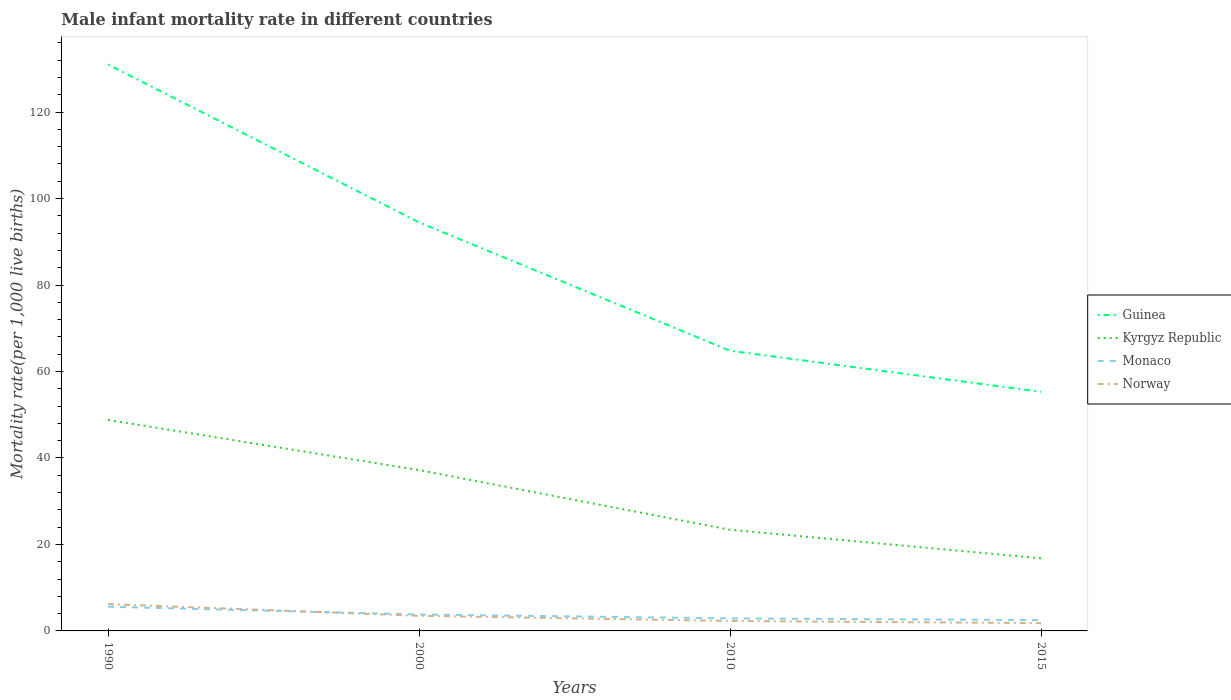Does the line corresponding to Monaco intersect with the line corresponding to Guinea?
Offer a terse response. No. In which year was the male infant mortality rate in Guinea maximum?
Keep it short and to the point. 2015. What is the total male infant mortality rate in Kyrgyz Republic in the graph?
Provide a short and direct response. 11.6. What is the difference between the highest and the second highest male infant mortality rate in Monaco?
Offer a very short reply. 3.1. What is the difference between the highest and the lowest male infant mortality rate in Monaco?
Your answer should be very brief. 2. How many years are there in the graph?
Ensure brevity in your answer.  4. Does the graph contain any zero values?
Make the answer very short. No. Does the graph contain grids?
Make the answer very short. No. Where does the legend appear in the graph?
Ensure brevity in your answer.  Center right. What is the title of the graph?
Your response must be concise. Male infant mortality rate in different countries. What is the label or title of the Y-axis?
Provide a succinct answer. Mortality rate(per 1,0 live births). What is the Mortality rate(per 1,000 live births) of Guinea in 1990?
Your answer should be compact. 131. What is the Mortality rate(per 1,000 live births) in Kyrgyz Republic in 1990?
Offer a terse response. 48.8. What is the Mortality rate(per 1,000 live births) of Monaco in 1990?
Make the answer very short. 5.6. What is the Mortality rate(per 1,000 live births) in Norway in 1990?
Provide a short and direct response. 6.2. What is the Mortality rate(per 1,000 live births) of Guinea in 2000?
Your answer should be very brief. 94.5. What is the Mortality rate(per 1,000 live births) of Kyrgyz Republic in 2000?
Provide a short and direct response. 37.2. What is the Mortality rate(per 1,000 live births) in Norway in 2000?
Provide a short and direct response. 3.5. What is the Mortality rate(per 1,000 live births) in Guinea in 2010?
Your response must be concise. 64.8. What is the Mortality rate(per 1,000 live births) in Kyrgyz Republic in 2010?
Make the answer very short. 23.4. What is the Mortality rate(per 1,000 live births) in Monaco in 2010?
Make the answer very short. 2.9. What is the Mortality rate(per 1,000 live births) of Guinea in 2015?
Your response must be concise. 55.3. What is the Mortality rate(per 1,000 live births) of Kyrgyz Republic in 2015?
Ensure brevity in your answer.  16.8. Across all years, what is the maximum Mortality rate(per 1,000 live births) in Guinea?
Provide a short and direct response. 131. Across all years, what is the maximum Mortality rate(per 1,000 live births) of Kyrgyz Republic?
Your answer should be compact. 48.8. Across all years, what is the maximum Mortality rate(per 1,000 live births) of Norway?
Offer a very short reply. 6.2. Across all years, what is the minimum Mortality rate(per 1,000 live births) of Guinea?
Your response must be concise. 55.3. Across all years, what is the minimum Mortality rate(per 1,000 live births) of Kyrgyz Republic?
Make the answer very short. 16.8. Across all years, what is the minimum Mortality rate(per 1,000 live births) of Monaco?
Provide a short and direct response. 2.5. Across all years, what is the minimum Mortality rate(per 1,000 live births) of Norway?
Offer a terse response. 1.8. What is the total Mortality rate(per 1,000 live births) of Guinea in the graph?
Keep it short and to the point. 345.6. What is the total Mortality rate(per 1,000 live births) of Kyrgyz Republic in the graph?
Keep it short and to the point. 126.2. What is the total Mortality rate(per 1,000 live births) of Norway in the graph?
Provide a short and direct response. 13.8. What is the difference between the Mortality rate(per 1,000 live births) in Guinea in 1990 and that in 2000?
Make the answer very short. 36.5. What is the difference between the Mortality rate(per 1,000 live births) of Guinea in 1990 and that in 2010?
Provide a succinct answer. 66.2. What is the difference between the Mortality rate(per 1,000 live births) of Kyrgyz Republic in 1990 and that in 2010?
Provide a succinct answer. 25.4. What is the difference between the Mortality rate(per 1,000 live births) of Monaco in 1990 and that in 2010?
Your answer should be compact. 2.7. What is the difference between the Mortality rate(per 1,000 live births) of Norway in 1990 and that in 2010?
Make the answer very short. 3.9. What is the difference between the Mortality rate(per 1,000 live births) of Guinea in 1990 and that in 2015?
Your answer should be very brief. 75.7. What is the difference between the Mortality rate(per 1,000 live births) in Kyrgyz Republic in 1990 and that in 2015?
Make the answer very short. 32. What is the difference between the Mortality rate(per 1,000 live births) of Norway in 1990 and that in 2015?
Provide a succinct answer. 4.4. What is the difference between the Mortality rate(per 1,000 live births) of Guinea in 2000 and that in 2010?
Provide a short and direct response. 29.7. What is the difference between the Mortality rate(per 1,000 live births) in Monaco in 2000 and that in 2010?
Make the answer very short. 0.9. What is the difference between the Mortality rate(per 1,000 live births) in Norway in 2000 and that in 2010?
Make the answer very short. 1.2. What is the difference between the Mortality rate(per 1,000 live births) of Guinea in 2000 and that in 2015?
Offer a terse response. 39.2. What is the difference between the Mortality rate(per 1,000 live births) in Kyrgyz Republic in 2000 and that in 2015?
Your response must be concise. 20.4. What is the difference between the Mortality rate(per 1,000 live births) in Guinea in 2010 and that in 2015?
Make the answer very short. 9.5. What is the difference between the Mortality rate(per 1,000 live births) of Kyrgyz Republic in 2010 and that in 2015?
Your answer should be very brief. 6.6. What is the difference between the Mortality rate(per 1,000 live births) of Norway in 2010 and that in 2015?
Provide a succinct answer. 0.5. What is the difference between the Mortality rate(per 1,000 live births) of Guinea in 1990 and the Mortality rate(per 1,000 live births) of Kyrgyz Republic in 2000?
Provide a short and direct response. 93.8. What is the difference between the Mortality rate(per 1,000 live births) of Guinea in 1990 and the Mortality rate(per 1,000 live births) of Monaco in 2000?
Give a very brief answer. 127.2. What is the difference between the Mortality rate(per 1,000 live births) of Guinea in 1990 and the Mortality rate(per 1,000 live births) of Norway in 2000?
Give a very brief answer. 127.5. What is the difference between the Mortality rate(per 1,000 live births) in Kyrgyz Republic in 1990 and the Mortality rate(per 1,000 live births) in Norway in 2000?
Your response must be concise. 45.3. What is the difference between the Mortality rate(per 1,000 live births) of Guinea in 1990 and the Mortality rate(per 1,000 live births) of Kyrgyz Republic in 2010?
Offer a very short reply. 107.6. What is the difference between the Mortality rate(per 1,000 live births) in Guinea in 1990 and the Mortality rate(per 1,000 live births) in Monaco in 2010?
Ensure brevity in your answer.  128.1. What is the difference between the Mortality rate(per 1,000 live births) in Guinea in 1990 and the Mortality rate(per 1,000 live births) in Norway in 2010?
Your answer should be very brief. 128.7. What is the difference between the Mortality rate(per 1,000 live births) in Kyrgyz Republic in 1990 and the Mortality rate(per 1,000 live births) in Monaco in 2010?
Ensure brevity in your answer.  45.9. What is the difference between the Mortality rate(per 1,000 live births) in Kyrgyz Republic in 1990 and the Mortality rate(per 1,000 live births) in Norway in 2010?
Your answer should be very brief. 46.5. What is the difference between the Mortality rate(per 1,000 live births) in Monaco in 1990 and the Mortality rate(per 1,000 live births) in Norway in 2010?
Offer a terse response. 3.3. What is the difference between the Mortality rate(per 1,000 live births) in Guinea in 1990 and the Mortality rate(per 1,000 live births) in Kyrgyz Republic in 2015?
Offer a terse response. 114.2. What is the difference between the Mortality rate(per 1,000 live births) of Guinea in 1990 and the Mortality rate(per 1,000 live births) of Monaco in 2015?
Offer a terse response. 128.5. What is the difference between the Mortality rate(per 1,000 live births) of Guinea in 1990 and the Mortality rate(per 1,000 live births) of Norway in 2015?
Give a very brief answer. 129.2. What is the difference between the Mortality rate(per 1,000 live births) of Kyrgyz Republic in 1990 and the Mortality rate(per 1,000 live births) of Monaco in 2015?
Your response must be concise. 46.3. What is the difference between the Mortality rate(per 1,000 live births) of Monaco in 1990 and the Mortality rate(per 1,000 live births) of Norway in 2015?
Provide a short and direct response. 3.8. What is the difference between the Mortality rate(per 1,000 live births) in Guinea in 2000 and the Mortality rate(per 1,000 live births) in Kyrgyz Republic in 2010?
Make the answer very short. 71.1. What is the difference between the Mortality rate(per 1,000 live births) of Guinea in 2000 and the Mortality rate(per 1,000 live births) of Monaco in 2010?
Your response must be concise. 91.6. What is the difference between the Mortality rate(per 1,000 live births) of Guinea in 2000 and the Mortality rate(per 1,000 live births) of Norway in 2010?
Make the answer very short. 92.2. What is the difference between the Mortality rate(per 1,000 live births) in Kyrgyz Republic in 2000 and the Mortality rate(per 1,000 live births) in Monaco in 2010?
Give a very brief answer. 34.3. What is the difference between the Mortality rate(per 1,000 live births) in Kyrgyz Republic in 2000 and the Mortality rate(per 1,000 live births) in Norway in 2010?
Your answer should be very brief. 34.9. What is the difference between the Mortality rate(per 1,000 live births) in Guinea in 2000 and the Mortality rate(per 1,000 live births) in Kyrgyz Republic in 2015?
Keep it short and to the point. 77.7. What is the difference between the Mortality rate(per 1,000 live births) in Guinea in 2000 and the Mortality rate(per 1,000 live births) in Monaco in 2015?
Keep it short and to the point. 92. What is the difference between the Mortality rate(per 1,000 live births) of Guinea in 2000 and the Mortality rate(per 1,000 live births) of Norway in 2015?
Offer a very short reply. 92.7. What is the difference between the Mortality rate(per 1,000 live births) in Kyrgyz Republic in 2000 and the Mortality rate(per 1,000 live births) in Monaco in 2015?
Your answer should be compact. 34.7. What is the difference between the Mortality rate(per 1,000 live births) of Kyrgyz Republic in 2000 and the Mortality rate(per 1,000 live births) of Norway in 2015?
Provide a succinct answer. 35.4. What is the difference between the Mortality rate(per 1,000 live births) of Monaco in 2000 and the Mortality rate(per 1,000 live births) of Norway in 2015?
Provide a succinct answer. 2. What is the difference between the Mortality rate(per 1,000 live births) of Guinea in 2010 and the Mortality rate(per 1,000 live births) of Monaco in 2015?
Give a very brief answer. 62.3. What is the difference between the Mortality rate(per 1,000 live births) of Kyrgyz Republic in 2010 and the Mortality rate(per 1,000 live births) of Monaco in 2015?
Provide a succinct answer. 20.9. What is the difference between the Mortality rate(per 1,000 live births) in Kyrgyz Republic in 2010 and the Mortality rate(per 1,000 live births) in Norway in 2015?
Offer a terse response. 21.6. What is the average Mortality rate(per 1,000 live births) in Guinea per year?
Your answer should be very brief. 86.4. What is the average Mortality rate(per 1,000 live births) of Kyrgyz Republic per year?
Make the answer very short. 31.55. What is the average Mortality rate(per 1,000 live births) in Norway per year?
Offer a very short reply. 3.45. In the year 1990, what is the difference between the Mortality rate(per 1,000 live births) of Guinea and Mortality rate(per 1,000 live births) of Kyrgyz Republic?
Your answer should be compact. 82.2. In the year 1990, what is the difference between the Mortality rate(per 1,000 live births) in Guinea and Mortality rate(per 1,000 live births) in Monaco?
Your response must be concise. 125.4. In the year 1990, what is the difference between the Mortality rate(per 1,000 live births) of Guinea and Mortality rate(per 1,000 live births) of Norway?
Provide a succinct answer. 124.8. In the year 1990, what is the difference between the Mortality rate(per 1,000 live births) of Kyrgyz Republic and Mortality rate(per 1,000 live births) of Monaco?
Offer a terse response. 43.2. In the year 1990, what is the difference between the Mortality rate(per 1,000 live births) of Kyrgyz Republic and Mortality rate(per 1,000 live births) of Norway?
Give a very brief answer. 42.6. In the year 2000, what is the difference between the Mortality rate(per 1,000 live births) of Guinea and Mortality rate(per 1,000 live births) of Kyrgyz Republic?
Offer a very short reply. 57.3. In the year 2000, what is the difference between the Mortality rate(per 1,000 live births) of Guinea and Mortality rate(per 1,000 live births) of Monaco?
Ensure brevity in your answer.  90.7. In the year 2000, what is the difference between the Mortality rate(per 1,000 live births) in Guinea and Mortality rate(per 1,000 live births) in Norway?
Offer a terse response. 91. In the year 2000, what is the difference between the Mortality rate(per 1,000 live births) of Kyrgyz Republic and Mortality rate(per 1,000 live births) of Monaco?
Offer a terse response. 33.4. In the year 2000, what is the difference between the Mortality rate(per 1,000 live births) in Kyrgyz Republic and Mortality rate(per 1,000 live births) in Norway?
Make the answer very short. 33.7. In the year 2000, what is the difference between the Mortality rate(per 1,000 live births) of Monaco and Mortality rate(per 1,000 live births) of Norway?
Ensure brevity in your answer.  0.3. In the year 2010, what is the difference between the Mortality rate(per 1,000 live births) of Guinea and Mortality rate(per 1,000 live births) of Kyrgyz Republic?
Your response must be concise. 41.4. In the year 2010, what is the difference between the Mortality rate(per 1,000 live births) of Guinea and Mortality rate(per 1,000 live births) of Monaco?
Provide a succinct answer. 61.9. In the year 2010, what is the difference between the Mortality rate(per 1,000 live births) in Guinea and Mortality rate(per 1,000 live births) in Norway?
Your answer should be compact. 62.5. In the year 2010, what is the difference between the Mortality rate(per 1,000 live births) in Kyrgyz Republic and Mortality rate(per 1,000 live births) in Monaco?
Offer a very short reply. 20.5. In the year 2010, what is the difference between the Mortality rate(per 1,000 live births) of Kyrgyz Republic and Mortality rate(per 1,000 live births) of Norway?
Give a very brief answer. 21.1. In the year 2010, what is the difference between the Mortality rate(per 1,000 live births) of Monaco and Mortality rate(per 1,000 live births) of Norway?
Keep it short and to the point. 0.6. In the year 2015, what is the difference between the Mortality rate(per 1,000 live births) of Guinea and Mortality rate(per 1,000 live births) of Kyrgyz Republic?
Offer a very short reply. 38.5. In the year 2015, what is the difference between the Mortality rate(per 1,000 live births) of Guinea and Mortality rate(per 1,000 live births) of Monaco?
Give a very brief answer. 52.8. In the year 2015, what is the difference between the Mortality rate(per 1,000 live births) of Guinea and Mortality rate(per 1,000 live births) of Norway?
Your answer should be compact. 53.5. In the year 2015, what is the difference between the Mortality rate(per 1,000 live births) in Kyrgyz Republic and Mortality rate(per 1,000 live births) in Monaco?
Ensure brevity in your answer.  14.3. In the year 2015, what is the difference between the Mortality rate(per 1,000 live births) in Monaco and Mortality rate(per 1,000 live births) in Norway?
Your answer should be very brief. 0.7. What is the ratio of the Mortality rate(per 1,000 live births) of Guinea in 1990 to that in 2000?
Provide a succinct answer. 1.39. What is the ratio of the Mortality rate(per 1,000 live births) of Kyrgyz Republic in 1990 to that in 2000?
Give a very brief answer. 1.31. What is the ratio of the Mortality rate(per 1,000 live births) of Monaco in 1990 to that in 2000?
Offer a terse response. 1.47. What is the ratio of the Mortality rate(per 1,000 live births) in Norway in 1990 to that in 2000?
Provide a succinct answer. 1.77. What is the ratio of the Mortality rate(per 1,000 live births) of Guinea in 1990 to that in 2010?
Your answer should be very brief. 2.02. What is the ratio of the Mortality rate(per 1,000 live births) of Kyrgyz Republic in 1990 to that in 2010?
Your answer should be very brief. 2.09. What is the ratio of the Mortality rate(per 1,000 live births) of Monaco in 1990 to that in 2010?
Give a very brief answer. 1.93. What is the ratio of the Mortality rate(per 1,000 live births) of Norway in 1990 to that in 2010?
Offer a very short reply. 2.7. What is the ratio of the Mortality rate(per 1,000 live births) in Guinea in 1990 to that in 2015?
Make the answer very short. 2.37. What is the ratio of the Mortality rate(per 1,000 live births) of Kyrgyz Republic in 1990 to that in 2015?
Your answer should be compact. 2.9. What is the ratio of the Mortality rate(per 1,000 live births) of Monaco in 1990 to that in 2015?
Your response must be concise. 2.24. What is the ratio of the Mortality rate(per 1,000 live births) of Norway in 1990 to that in 2015?
Offer a very short reply. 3.44. What is the ratio of the Mortality rate(per 1,000 live births) of Guinea in 2000 to that in 2010?
Provide a short and direct response. 1.46. What is the ratio of the Mortality rate(per 1,000 live births) in Kyrgyz Republic in 2000 to that in 2010?
Your answer should be compact. 1.59. What is the ratio of the Mortality rate(per 1,000 live births) of Monaco in 2000 to that in 2010?
Your response must be concise. 1.31. What is the ratio of the Mortality rate(per 1,000 live births) of Norway in 2000 to that in 2010?
Your answer should be compact. 1.52. What is the ratio of the Mortality rate(per 1,000 live births) of Guinea in 2000 to that in 2015?
Your response must be concise. 1.71. What is the ratio of the Mortality rate(per 1,000 live births) of Kyrgyz Republic in 2000 to that in 2015?
Offer a very short reply. 2.21. What is the ratio of the Mortality rate(per 1,000 live births) in Monaco in 2000 to that in 2015?
Provide a short and direct response. 1.52. What is the ratio of the Mortality rate(per 1,000 live births) in Norway in 2000 to that in 2015?
Give a very brief answer. 1.94. What is the ratio of the Mortality rate(per 1,000 live births) in Guinea in 2010 to that in 2015?
Offer a terse response. 1.17. What is the ratio of the Mortality rate(per 1,000 live births) in Kyrgyz Republic in 2010 to that in 2015?
Ensure brevity in your answer.  1.39. What is the ratio of the Mortality rate(per 1,000 live births) in Monaco in 2010 to that in 2015?
Ensure brevity in your answer.  1.16. What is the ratio of the Mortality rate(per 1,000 live births) in Norway in 2010 to that in 2015?
Offer a very short reply. 1.28. What is the difference between the highest and the second highest Mortality rate(per 1,000 live births) of Guinea?
Provide a succinct answer. 36.5. What is the difference between the highest and the second highest Mortality rate(per 1,000 live births) of Kyrgyz Republic?
Your answer should be very brief. 11.6. What is the difference between the highest and the second highest Mortality rate(per 1,000 live births) of Norway?
Offer a terse response. 2.7. What is the difference between the highest and the lowest Mortality rate(per 1,000 live births) of Guinea?
Provide a short and direct response. 75.7. What is the difference between the highest and the lowest Mortality rate(per 1,000 live births) in Kyrgyz Republic?
Make the answer very short. 32. What is the difference between the highest and the lowest Mortality rate(per 1,000 live births) in Norway?
Your answer should be very brief. 4.4. 